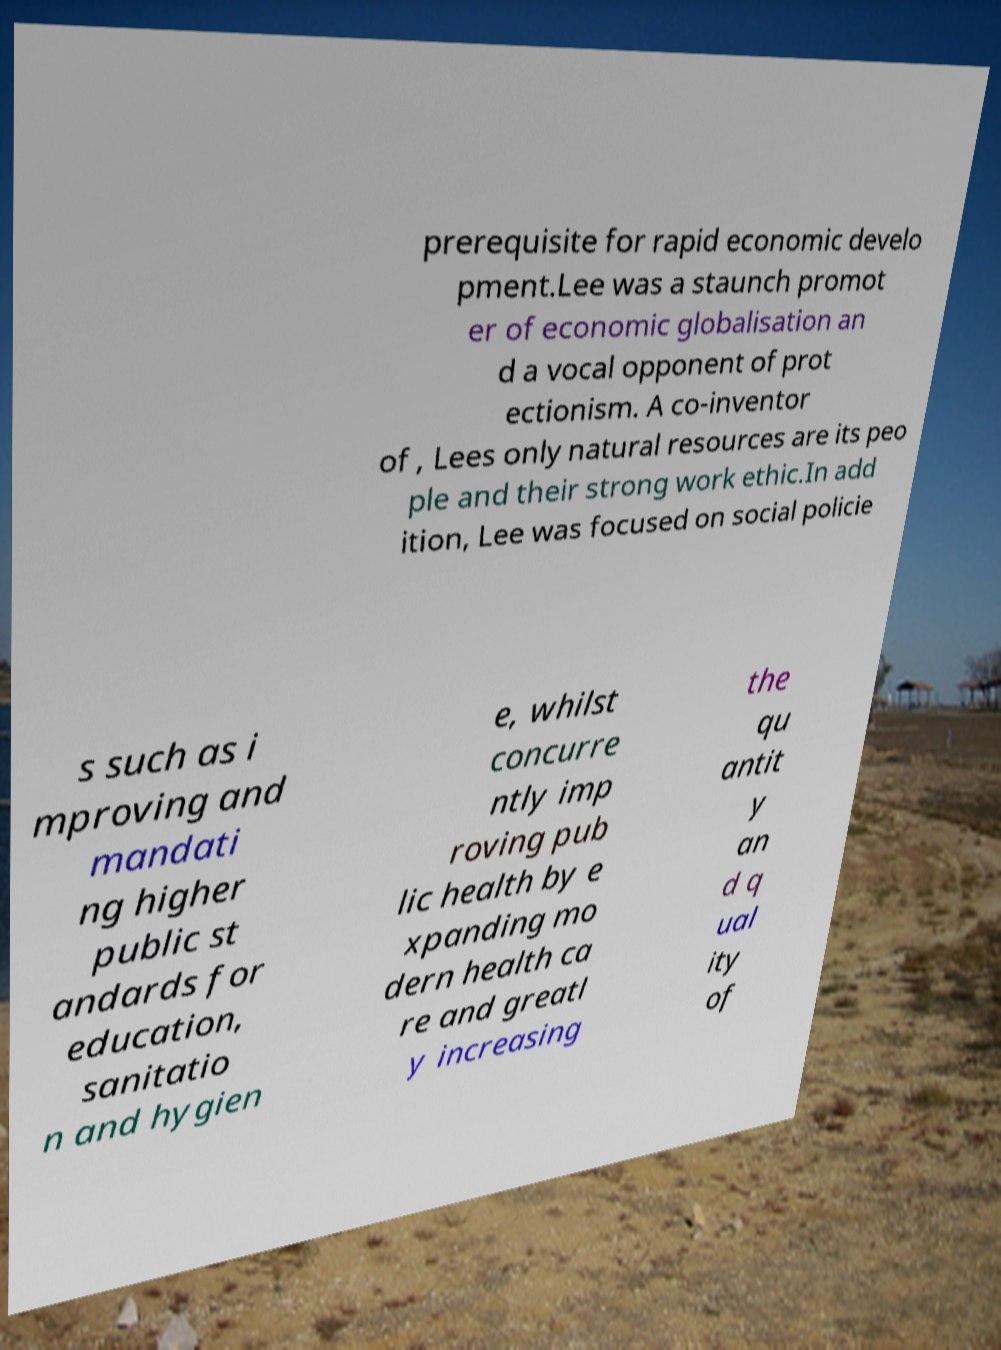Can you accurately transcribe the text from the provided image for me? prerequisite for rapid economic develo pment.Lee was a staunch promot er of economic globalisation an d a vocal opponent of prot ectionism. A co-inventor of , Lees only natural resources are its peo ple and their strong work ethic.In add ition, Lee was focused on social policie s such as i mproving and mandati ng higher public st andards for education, sanitatio n and hygien e, whilst concurre ntly imp roving pub lic health by e xpanding mo dern health ca re and greatl y increasing the qu antit y an d q ual ity of 